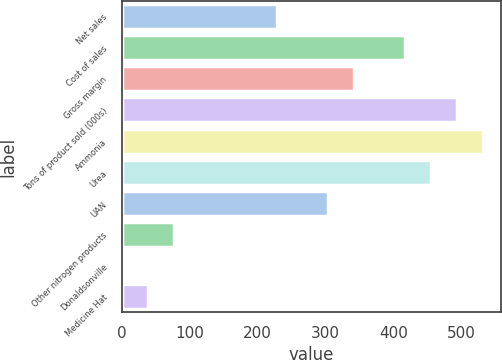<chart> <loc_0><loc_0><loc_500><loc_500><bar_chart><fcel>Net sales<fcel>Cost of sales<fcel>Gross margin<fcel>Tons of product sold (000s)<fcel>Ammonia<fcel>Urea<fcel>UAN<fcel>Other nitrogen products<fcel>Donaldsonville<fcel>Medicine Hat<nl><fcel>228.02<fcel>417.97<fcel>341.99<fcel>493.95<fcel>531.94<fcel>455.96<fcel>304<fcel>76.06<fcel>0.08<fcel>38.07<nl></chart> 